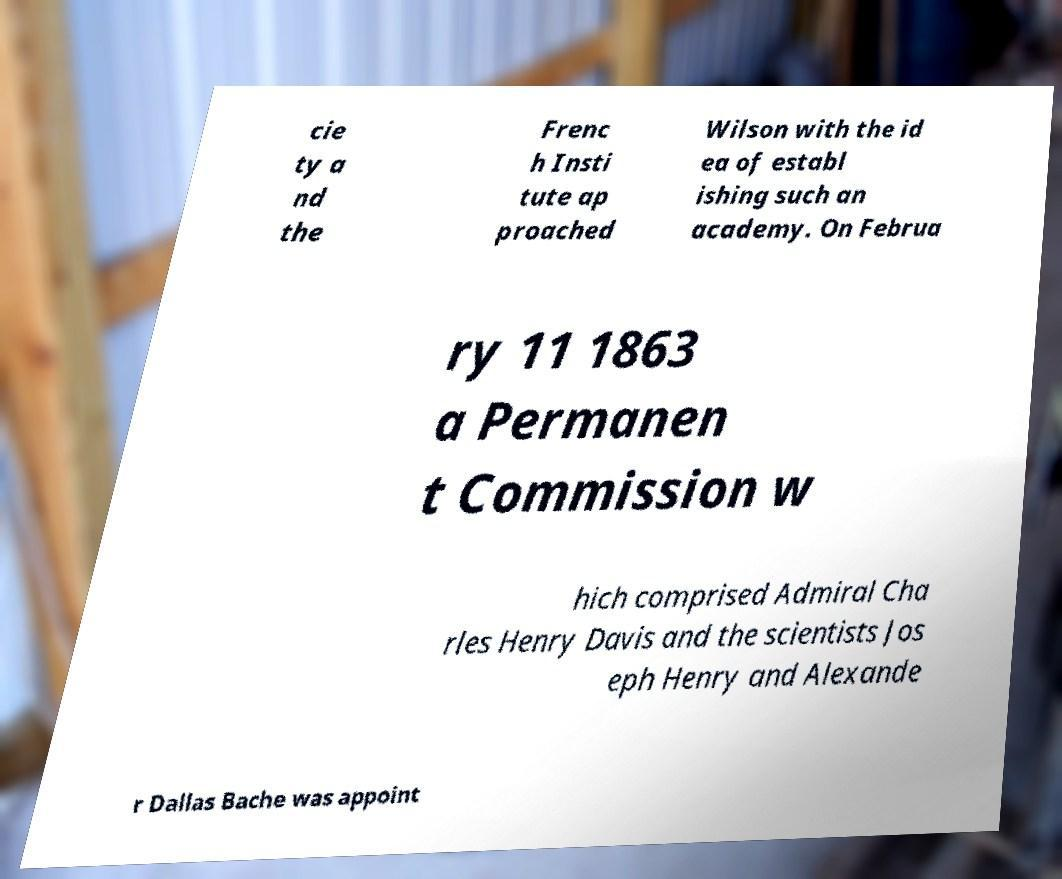Please read and relay the text visible in this image. What does it say? cie ty a nd the Frenc h Insti tute ap proached Wilson with the id ea of establ ishing such an academy. On Februa ry 11 1863 a Permanen t Commission w hich comprised Admiral Cha rles Henry Davis and the scientists Jos eph Henry and Alexande r Dallas Bache was appoint 